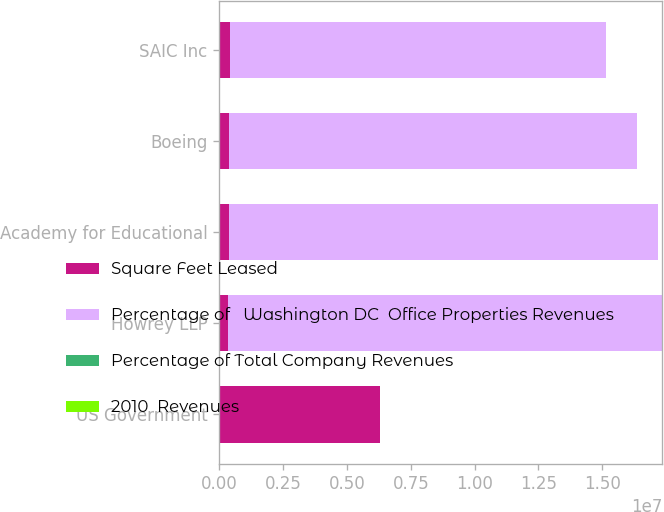Convert chart to OTSL. <chart><loc_0><loc_0><loc_500><loc_500><stacked_bar_chart><ecel><fcel>US Government<fcel>Howrey LLP<fcel>Academy for Educational<fcel>Boeing<fcel>SAIC Inc<nl><fcel>Square Feet Leased<fcel>6.277e+06<fcel>327000<fcel>368000<fcel>378000<fcel>433000<nl><fcel>Percentage of   Washington DC  Office Properties Revenues<fcel>28.9<fcel>1.7013e+07<fcel>1.6824e+07<fcel>1.5978e+07<fcel>1.4711e+07<nl><fcel>Percentage of Total Company Revenues<fcel>28.9<fcel>2.6<fcel>2.5<fcel>2.4<fcel>2.2<nl><fcel>2010  Revenues<fcel>6.9<fcel>0.6<fcel>0.6<fcel>0.6<fcel>0.5<nl></chart> 